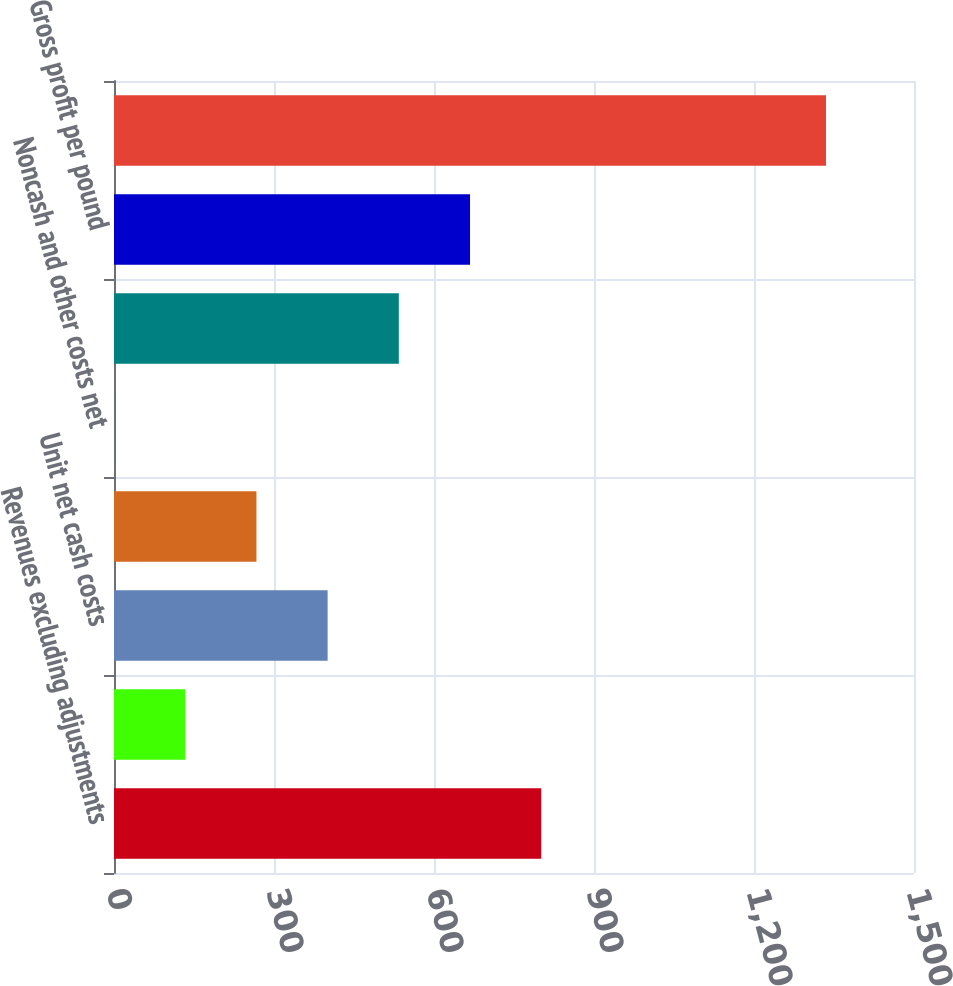Convert chart. <chart><loc_0><loc_0><loc_500><loc_500><bar_chart><fcel>Revenues excluding adjustments<fcel>Treatment charges<fcel>Unit net cash costs<fcel>Depreciation depletion and<fcel>Noncash and other costs net<fcel>Total unit costs<fcel>Gross profit per pound<fcel>Copper sales (millions of<nl><fcel>801.03<fcel>133.55<fcel>400.55<fcel>267.05<fcel>0.05<fcel>534.05<fcel>667.54<fcel>1335<nl></chart> 